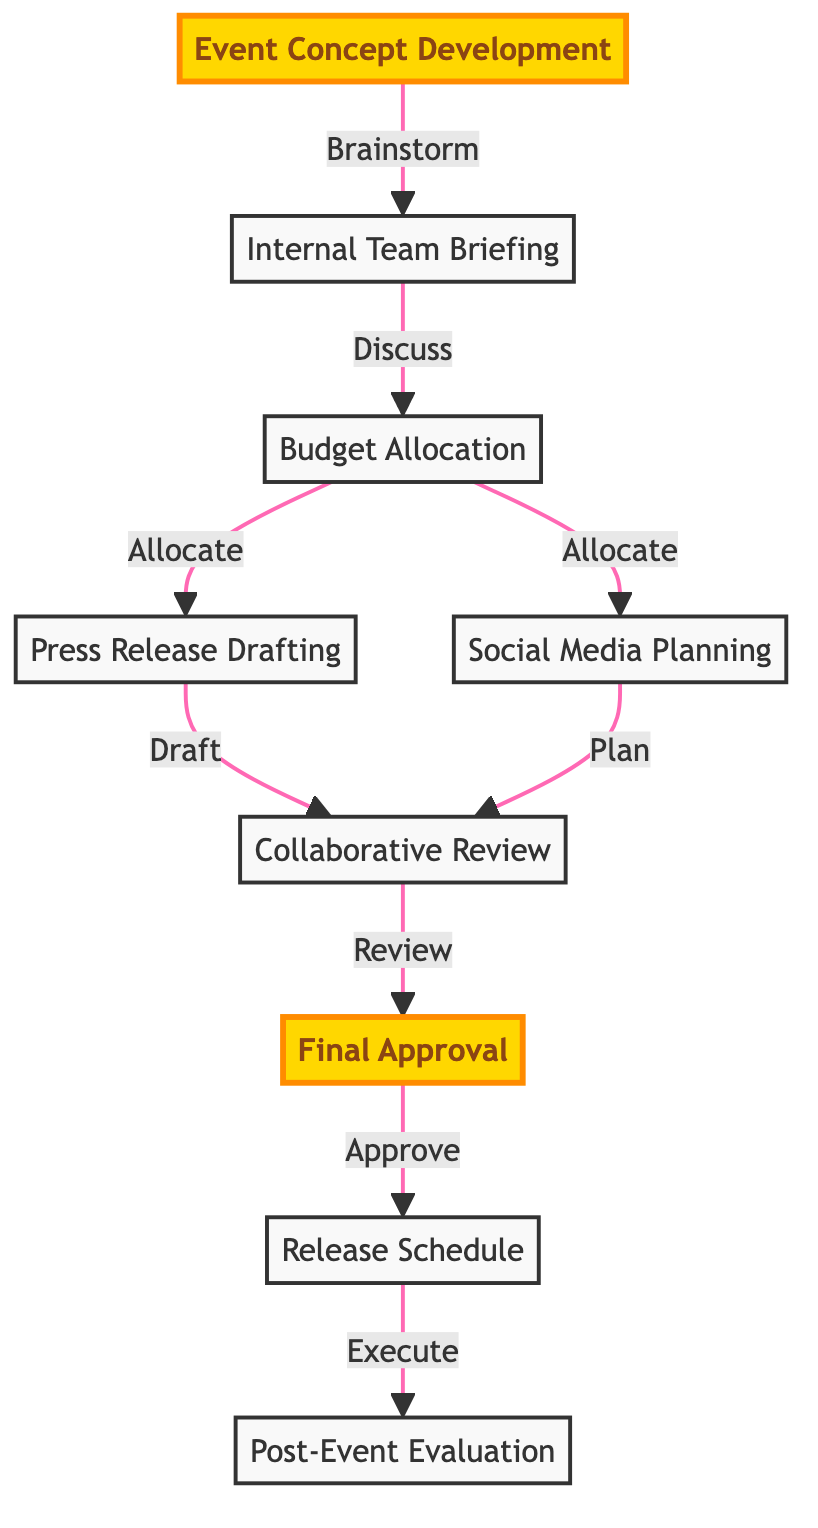What's the first step in the internal communication flow? The first step in the internal communication flow is "Event Concept Development," which involves brainstorming and outlining the theme and objectives of the event.
Answer: Event Concept Development How many major steps are there in the diagram? By counting the nodes represented in the diagram, there are a total of nine major steps outlined in the internal communication flow.
Answer: Nine What happens after the "Internal Team Briefing"? After the "Internal Team Briefing," the next steps are "Budget Allocation," where the budget for the event is determined.
Answer: Budget Allocation Which two nodes receive input from "Budget Allocation"? "Budget Allocation" outputs to both "Press Release Drafting" and "Social Media Planning," indicating that both areas depend on the budget determined.
Answer: Press Release Drafting and Social Media Planning What is the final step in the communication flow? The final step in the internal communication flow is "Post-Event Evaluation," which reviews event success and media coverage and gathers feedback.
Answer: Post-Event Evaluation What is the main purpose of the "Collaborative Review"? The "Collaborative Review" serves as a stage for gathering feedback from the team on the event plan and press release, ensuring clarity and agreement among all involved.
Answer: Gathering feedback Explain how the press release is created in this flow. The press release is created after the budget is allocated, by drafting a press release in "Press Release Drafting," following input and planning from both the budget decision and the social media strategy development.
Answer: By drafting after budget allocation Which nodes highlight the approval stages in the flow? The nodes that highlight the approval stages in the flow are "Final Approval," which is signified by the management or key stakeholders' sign-off before proceeding, and it specifically marks a significant point of finalization.
Answer: Final Approval How does the diagram indicate the relationship between social media and press releases? The relationship is indicated through the "Collaborative Review," where both the "Press Release Drafting" and "Social Media Planning" converge for feedback, emphasizing that these areas support one another in promoting the event.
Answer: Through Collaborative Review 